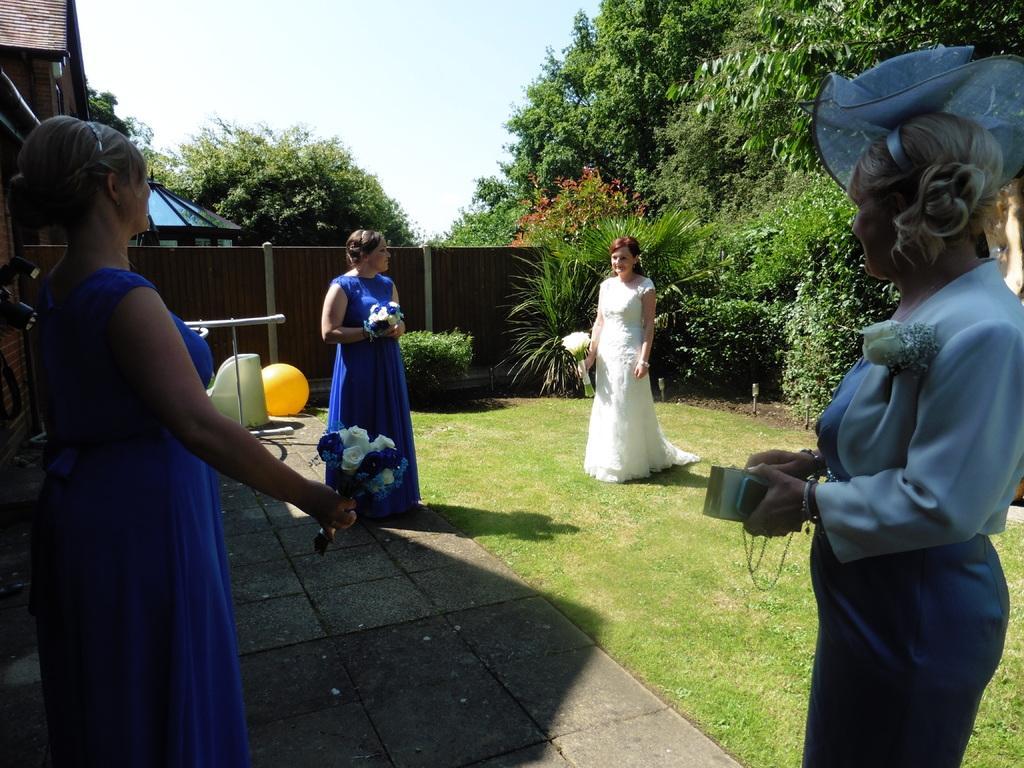Could you give a brief overview of what you see in this image? In this image there is a bride and three other bridesmaids standing in the backyard of a house by holding flower bouquets in their hands, in the background of the image there are trees and a house. 